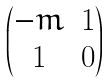<formula> <loc_0><loc_0><loc_500><loc_500>\begin{pmatrix} - m & 1 \\ 1 & 0 \end{pmatrix}</formula> 